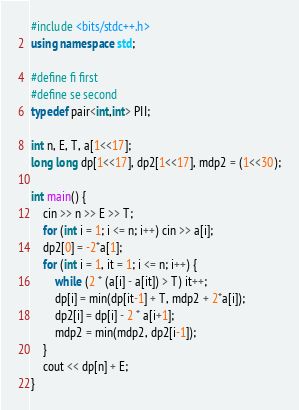<code> <loc_0><loc_0><loc_500><loc_500><_C++_>#include <bits/stdc++.h>
using namespace std;

#define fi first
#define se second
typedef pair<int,int> PII;

int n, E, T, a[1<<17];
long long dp[1<<17], dp2[1<<17], mdp2 = (1<<30);

int main() {
    cin >> n >> E >> T;
    for (int i = 1; i <= n; i++) cin >> a[i];
    dp2[0] = -2*a[1];
    for (int i = 1, it = 1; i <= n; i++) {
        while (2 * (a[i] - a[it]) > T) it++;
        dp[i] = min(dp[it-1] + T, mdp2 + 2*a[i]);
        dp2[i] = dp[i] - 2 * a[i+1];
        mdp2 = min(mdp2, dp2[i-1]);
    }
    cout << dp[n] + E;
}
</code> 